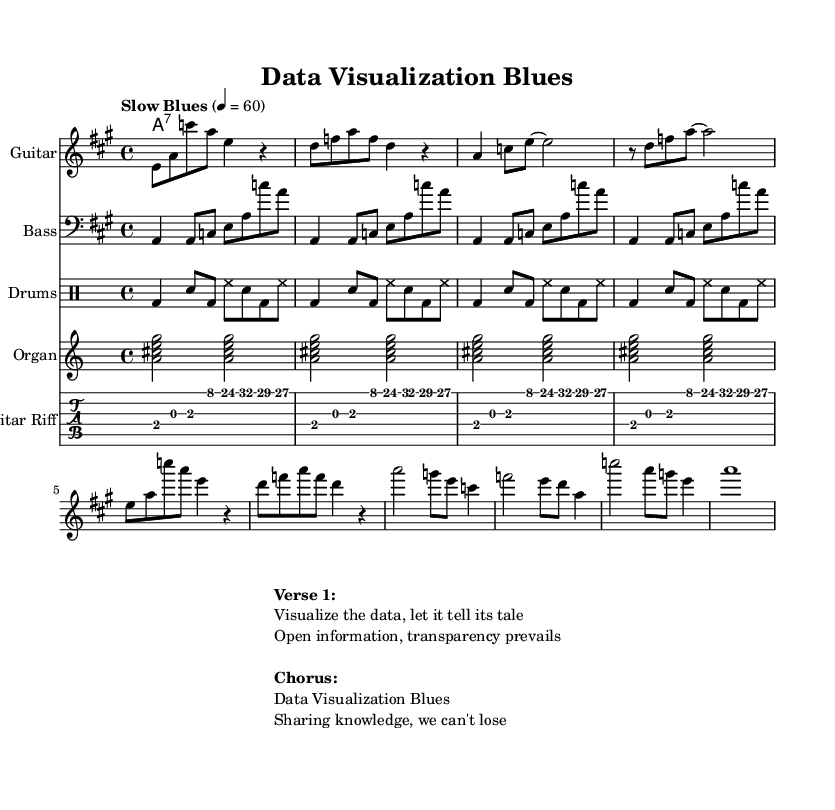What is the key signature of this music? The key signature is A major, which has three sharps (F#, C#, and G#). This can be identified at the beginning of the staff where the sharps are indicated.
Answer: A major What is the time signature of the piece? The time signature is 4/4, which means there are four beats in each measure and a quarter note receives one beat. This is indicated at the beginning of the score.
Answer: 4/4 What is the tempo marking for this piece? The tempo marking is "Slow Blues," and it indicates a slower pace at 60 beats per minute, which is noted at the start of the score.
Answer: Slow Blues How many measures are in the chorus section? The chorus section contains 4 measures, as can be counted directly from the notation provided in the score.
Answer: 4 What type of chords are indicated for the organ part? The chords indicated for the organ part are dominant seventh chords, specifically A7. This is determined from the chord notation "a2:7" repeated throughout.
Answer: dominant seventh How does the bass line relate to the chord progression? The bass line outlines the tonic (A) and arpeggiates through the chord tones of A major, reinforcing the harmony, as it's largely composed of the root (A), third (C#), and fifth (E) of the A major chord. This reflects the structure typical in electric blues.
Answer: outlines tonic What is the main theme conveyed in the lyrics of the verse? The main theme of the verse expresses the notion of data and information transparency, focusing on the importance of visualizing data to convey its story. This interpretation comes from analyzing the lyrics presented above the music.
Answer: data transparency 